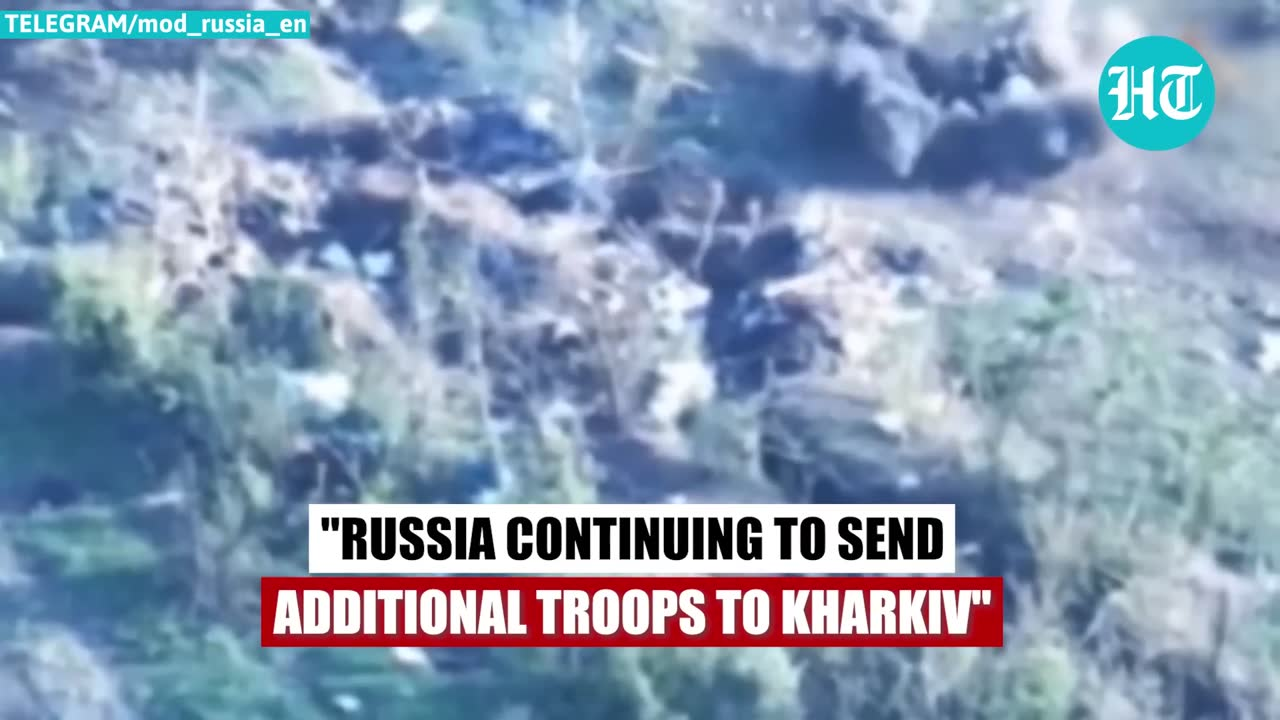describe the img The image displays a blurred aerial or satellite view of a terrain, predominantly in blue and green shades, possibly indicating a mix of water bodies and forested areas. Overlaying the image is a text banner with the message: "RUSSIA CONTINUING TO SEND ADDITIONAL TROOPS TO KHARKIV." Additionally, there's a logo on the top right that reads "HT", and a watermark at the top left corner that says "TELEGRAM/mod_russia_en", suggesting the image might be from or shared by a Telegram channel named "mod_russia_en". 